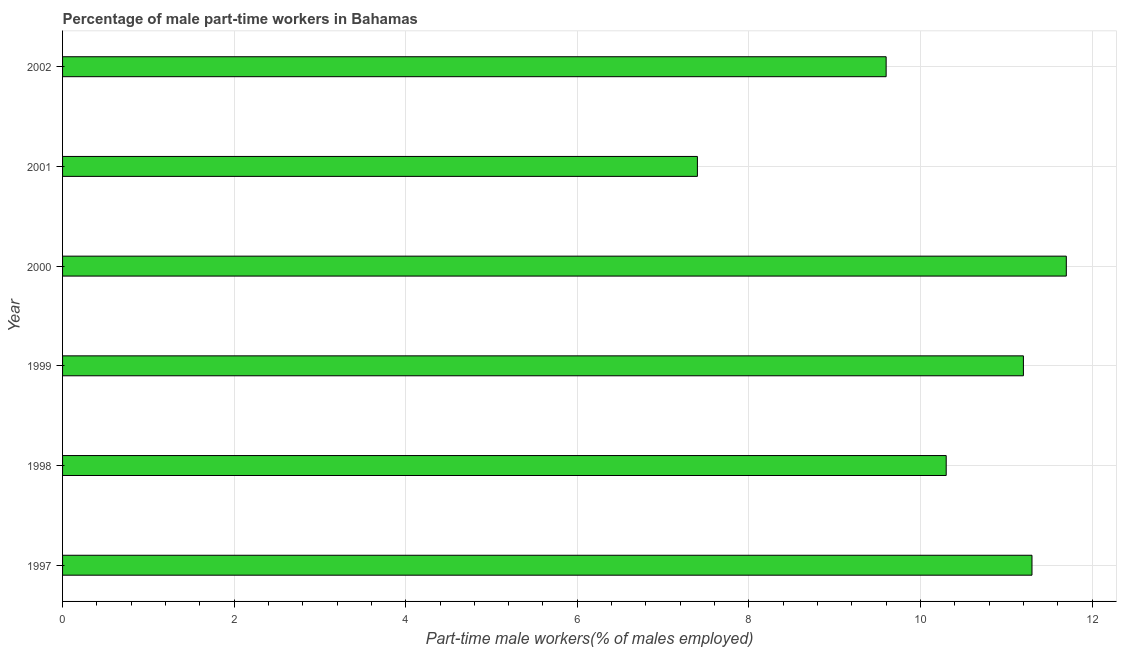What is the title of the graph?
Ensure brevity in your answer.  Percentage of male part-time workers in Bahamas. What is the label or title of the X-axis?
Provide a short and direct response. Part-time male workers(% of males employed). What is the label or title of the Y-axis?
Give a very brief answer. Year. What is the percentage of part-time male workers in 1999?
Offer a very short reply. 11.2. Across all years, what is the maximum percentage of part-time male workers?
Ensure brevity in your answer.  11.7. Across all years, what is the minimum percentage of part-time male workers?
Provide a succinct answer. 7.4. In which year was the percentage of part-time male workers maximum?
Give a very brief answer. 2000. In which year was the percentage of part-time male workers minimum?
Make the answer very short. 2001. What is the sum of the percentage of part-time male workers?
Your response must be concise. 61.5. What is the difference between the percentage of part-time male workers in 1997 and 2002?
Offer a terse response. 1.7. What is the average percentage of part-time male workers per year?
Make the answer very short. 10.25. What is the median percentage of part-time male workers?
Offer a very short reply. 10.75. In how many years, is the percentage of part-time male workers greater than 0.8 %?
Your answer should be very brief. 6. What is the ratio of the percentage of part-time male workers in 2000 to that in 2002?
Make the answer very short. 1.22. Is the difference between the percentage of part-time male workers in 1998 and 1999 greater than the difference between any two years?
Provide a succinct answer. No. Is the sum of the percentage of part-time male workers in 1997 and 2002 greater than the maximum percentage of part-time male workers across all years?
Your answer should be compact. Yes. In how many years, is the percentage of part-time male workers greater than the average percentage of part-time male workers taken over all years?
Give a very brief answer. 4. How many years are there in the graph?
Offer a terse response. 6. What is the difference between two consecutive major ticks on the X-axis?
Ensure brevity in your answer.  2. Are the values on the major ticks of X-axis written in scientific E-notation?
Provide a succinct answer. No. What is the Part-time male workers(% of males employed) in 1997?
Provide a succinct answer. 11.3. What is the Part-time male workers(% of males employed) in 1998?
Provide a short and direct response. 10.3. What is the Part-time male workers(% of males employed) of 1999?
Your answer should be compact. 11.2. What is the Part-time male workers(% of males employed) of 2000?
Your answer should be compact. 11.7. What is the Part-time male workers(% of males employed) in 2001?
Give a very brief answer. 7.4. What is the Part-time male workers(% of males employed) of 2002?
Make the answer very short. 9.6. What is the difference between the Part-time male workers(% of males employed) in 1997 and 2000?
Offer a terse response. -0.4. What is the difference between the Part-time male workers(% of males employed) in 1998 and 1999?
Your answer should be compact. -0.9. What is the difference between the Part-time male workers(% of males employed) in 1998 and 2002?
Provide a short and direct response. 0.7. What is the difference between the Part-time male workers(% of males employed) in 1999 and 2000?
Your answer should be very brief. -0.5. What is the difference between the Part-time male workers(% of males employed) in 1999 and 2001?
Offer a very short reply. 3.8. What is the difference between the Part-time male workers(% of males employed) in 2000 and 2002?
Ensure brevity in your answer.  2.1. What is the difference between the Part-time male workers(% of males employed) in 2001 and 2002?
Provide a short and direct response. -2.2. What is the ratio of the Part-time male workers(% of males employed) in 1997 to that in 1998?
Provide a short and direct response. 1.1. What is the ratio of the Part-time male workers(% of males employed) in 1997 to that in 1999?
Provide a succinct answer. 1.01. What is the ratio of the Part-time male workers(% of males employed) in 1997 to that in 2001?
Your response must be concise. 1.53. What is the ratio of the Part-time male workers(% of males employed) in 1997 to that in 2002?
Offer a very short reply. 1.18. What is the ratio of the Part-time male workers(% of males employed) in 1998 to that in 2001?
Give a very brief answer. 1.39. What is the ratio of the Part-time male workers(% of males employed) in 1998 to that in 2002?
Provide a short and direct response. 1.07. What is the ratio of the Part-time male workers(% of males employed) in 1999 to that in 2000?
Give a very brief answer. 0.96. What is the ratio of the Part-time male workers(% of males employed) in 1999 to that in 2001?
Provide a short and direct response. 1.51. What is the ratio of the Part-time male workers(% of males employed) in 1999 to that in 2002?
Ensure brevity in your answer.  1.17. What is the ratio of the Part-time male workers(% of males employed) in 2000 to that in 2001?
Provide a succinct answer. 1.58. What is the ratio of the Part-time male workers(% of males employed) in 2000 to that in 2002?
Ensure brevity in your answer.  1.22. What is the ratio of the Part-time male workers(% of males employed) in 2001 to that in 2002?
Give a very brief answer. 0.77. 